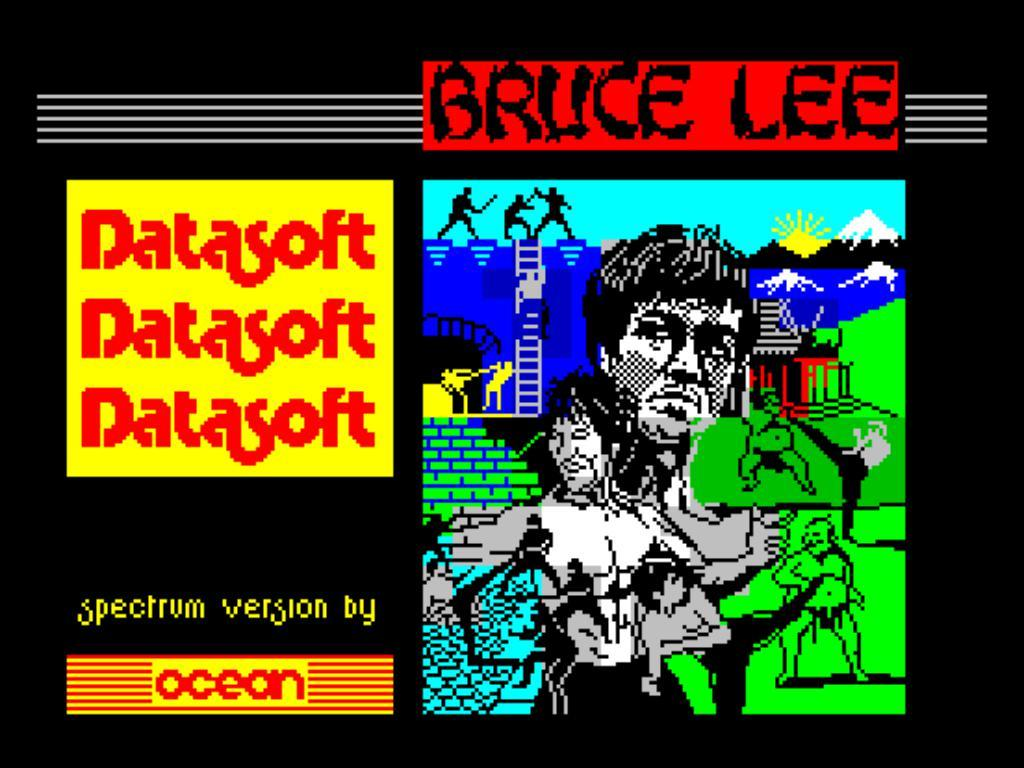Provide a one-sentence caption for the provided image. A poster of a Bruce Lee picture with Datasoft advertised next to it. 